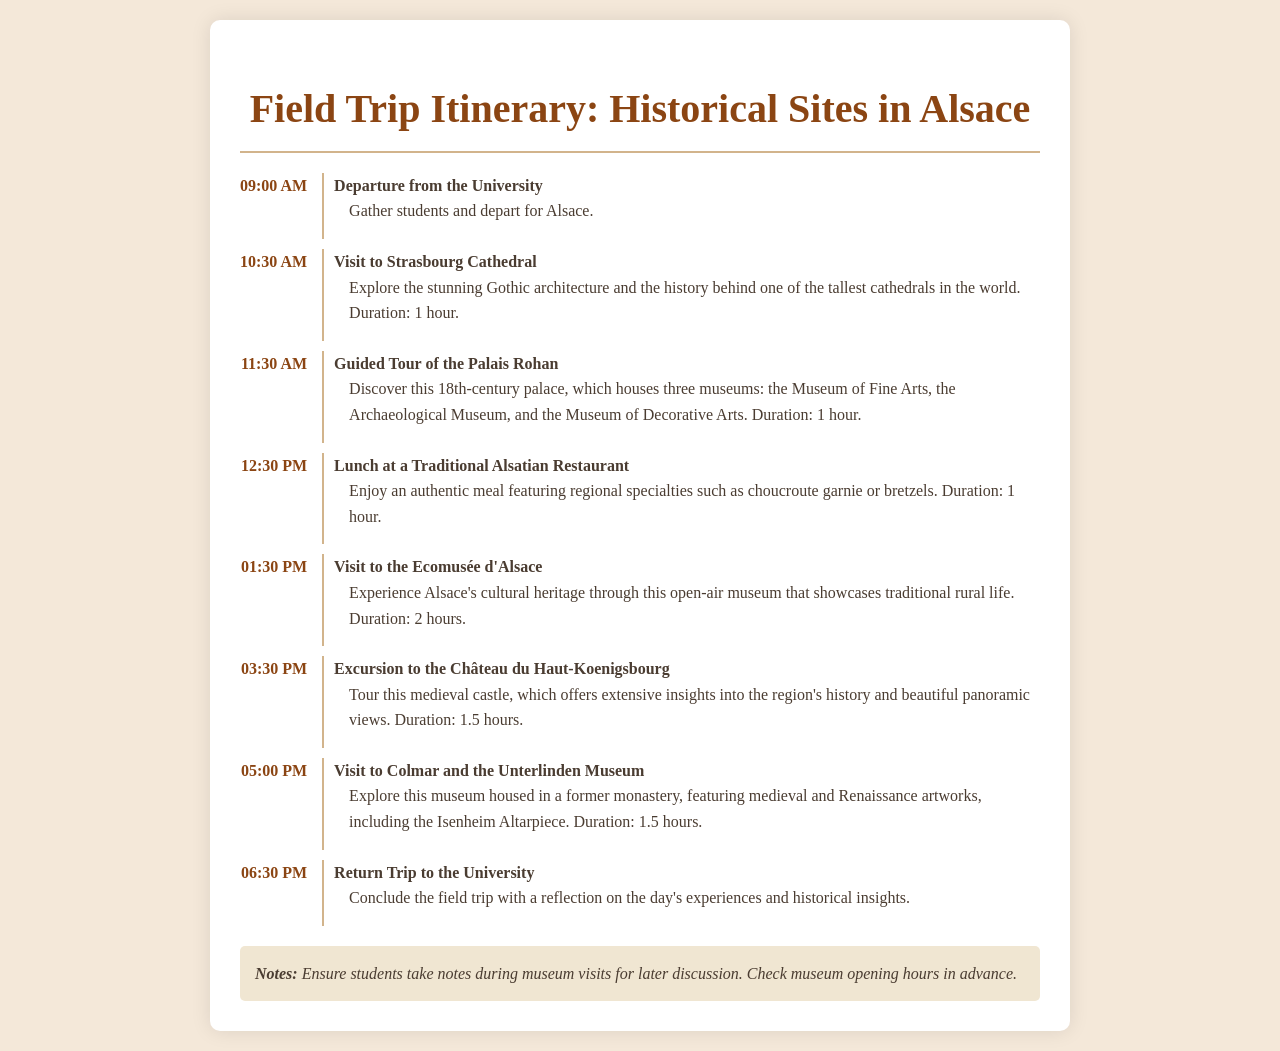What time does the field trip depart from the University? The schedule lists the time of departure from the University as 09:00 AM.
Answer: 09:00 AM How long is the visit to the Ecomusée d'Alsace? The document states that the duration of the visit to the Ecomusée d'Alsace is 2 hours.
Answer: 2 hours What is the name of the museum that features the Isenheim Altarpiece? The document mentions that the Unterlinden Museum in Colmar houses the Isenheim Altarpiece.
Answer: Unterlinden Museum What activity occurs immediately after the lunch break? The itinerary shows that the visit to the Ecomusée d'Alsace takes place after lunch.
Answer: Visit to the Ecomusée d'Alsace How many museums are housed in the Palais Rohan? The document notes that the Palais Rohan houses three museums.
Answer: Three museums What historical structure is visited after the Ecomusée d'Alsace? The schedule indicates the excursion to the Château du Haut-Koenigsbourg follows the visit to the Ecomusée d'Alsace.
Answer: Château du Haut-Koenigsbourg What is the duration of the guided tour of the Palais Rohan? According to the document, the guided tour of the Palais Rohan lasts for 1 hour.
Answer: 1 hour What is the last activity listed in the itinerary? The final activity in the schedule is the return trip to the University.
Answer: Return Trip to the University How long is the visit to Strasbourg Cathedral? The document specifies that the visit to Strasbourg Cathedral lasts for 1 hour.
Answer: 1 hour 